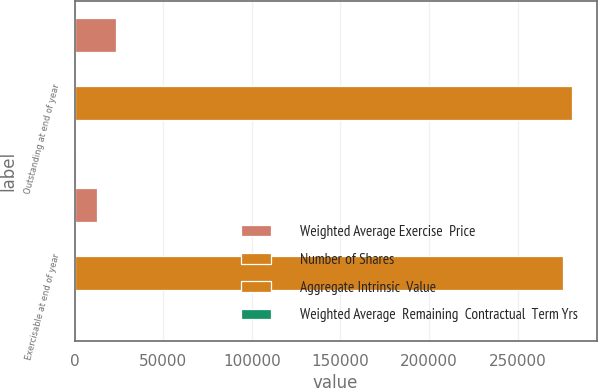<chart> <loc_0><loc_0><loc_500><loc_500><stacked_bar_chart><ecel><fcel>Outstanding at end of year<fcel>Exercisable at end of year<nl><fcel>Weighted Average Exercise  Price<fcel>23601<fcel>12662<nl><fcel>Number of Shares<fcel>40.33<fcel>26.19<nl><fcel>Aggregate Intrinsic  Value<fcel>280586<fcel>275484<nl><fcel>Weighted Average  Remaining  Contractual  Term Yrs<fcel>6<fcel>4.14<nl></chart> 